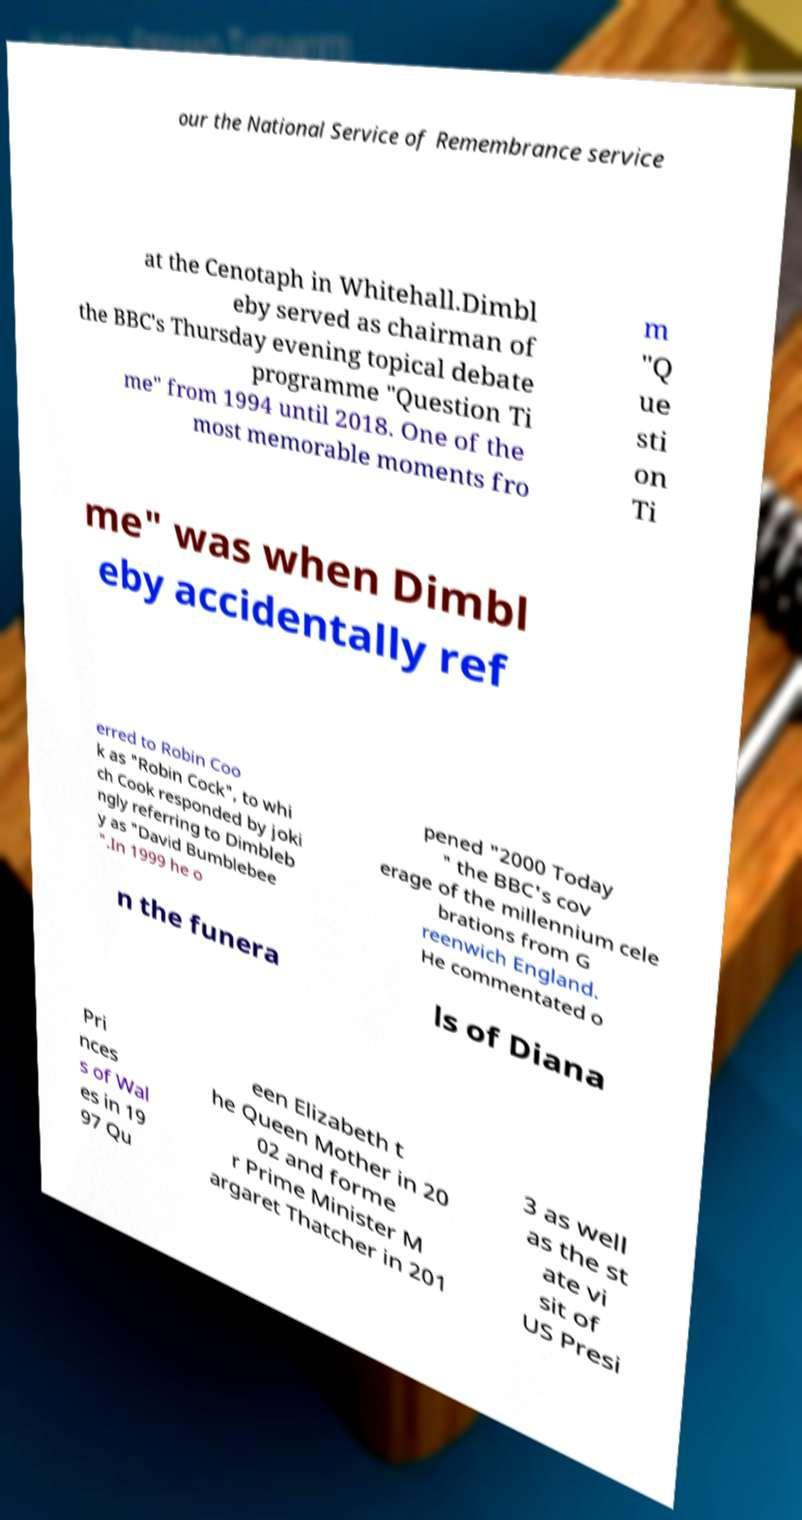What messages or text are displayed in this image? I need them in a readable, typed format. our the National Service of Remembrance service at the Cenotaph in Whitehall.Dimbl eby served as chairman of the BBC's Thursday evening topical debate programme "Question Ti me" from 1994 until 2018. One of the most memorable moments fro m "Q ue sti on Ti me" was when Dimbl eby accidentally ref erred to Robin Coo k as "Robin Cock", to whi ch Cook responded by joki ngly referring to Dimbleb y as "David Bumblebee ".In 1999 he o pened "2000 Today " the BBC's cov erage of the millennium cele brations from G reenwich England. He commentated o n the funera ls of Diana Pri nces s of Wal es in 19 97 Qu een Elizabeth t he Queen Mother in 20 02 and forme r Prime Minister M argaret Thatcher in 201 3 as well as the st ate vi sit of US Presi 